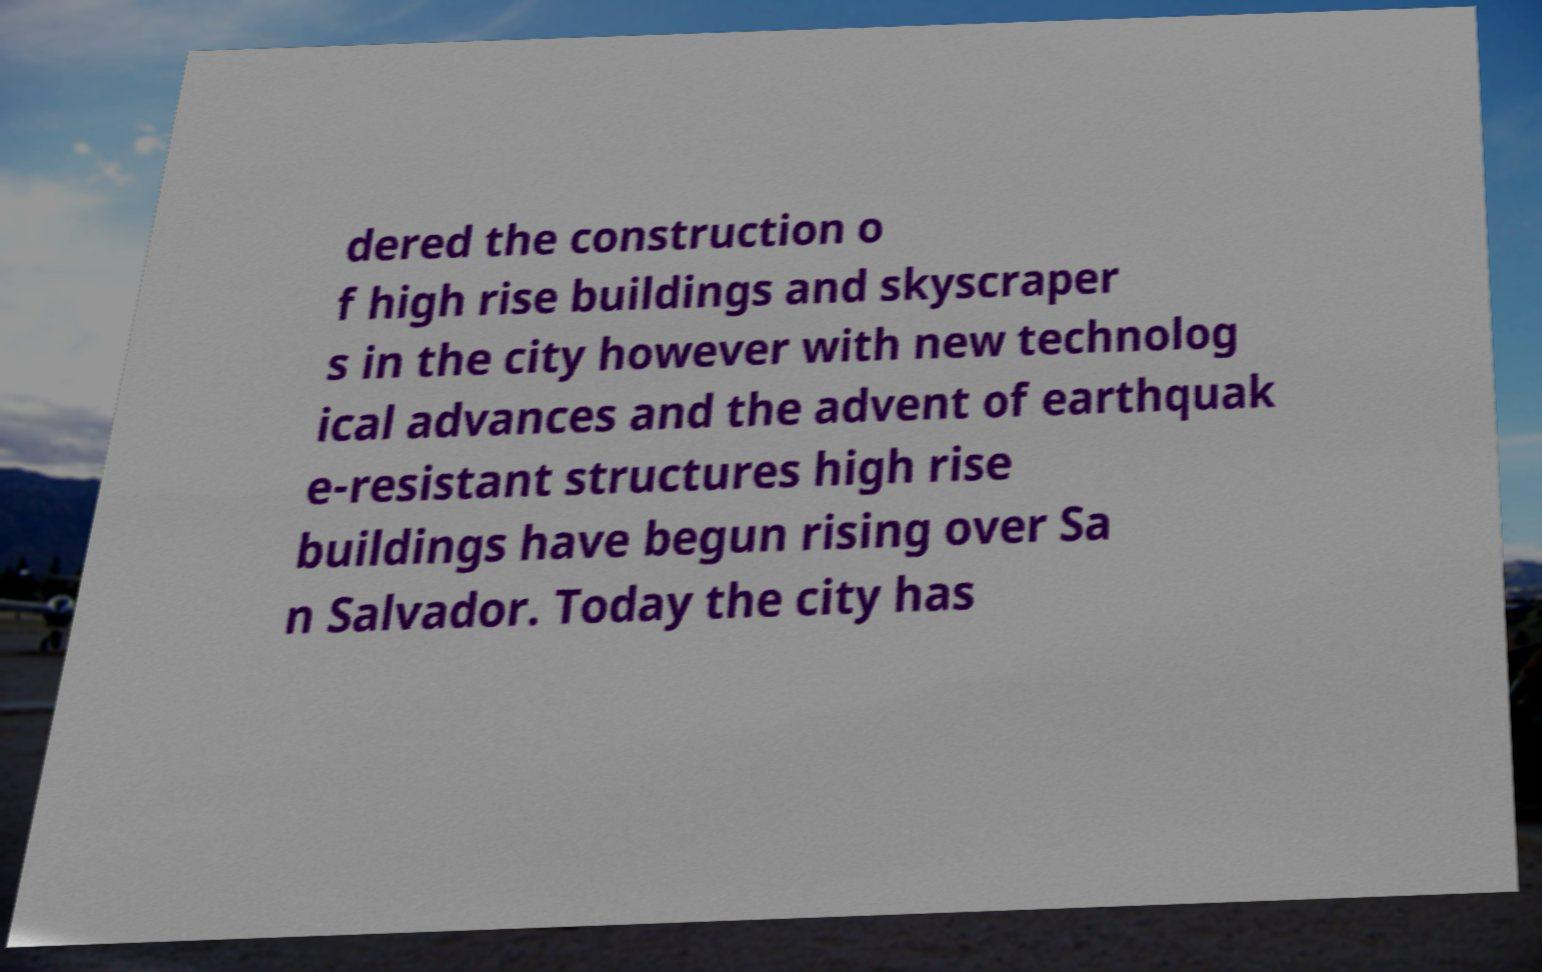There's text embedded in this image that I need extracted. Can you transcribe it verbatim? dered the construction o f high rise buildings and skyscraper s in the city however with new technolog ical advances and the advent of earthquak e-resistant structures high rise buildings have begun rising over Sa n Salvador. Today the city has 